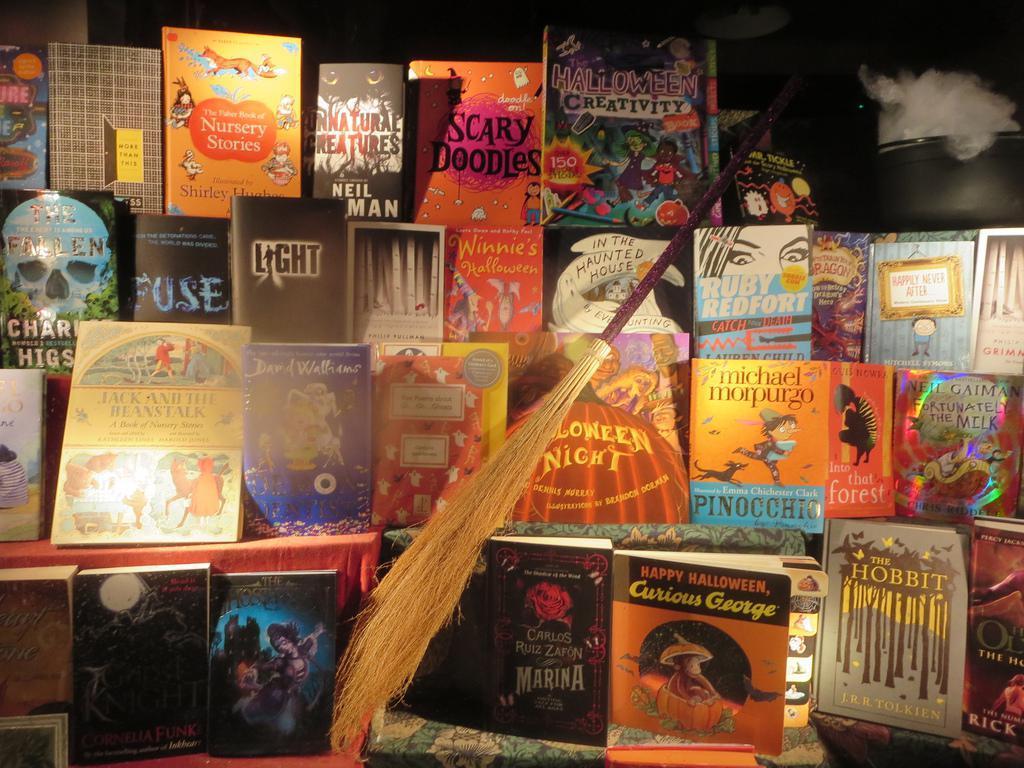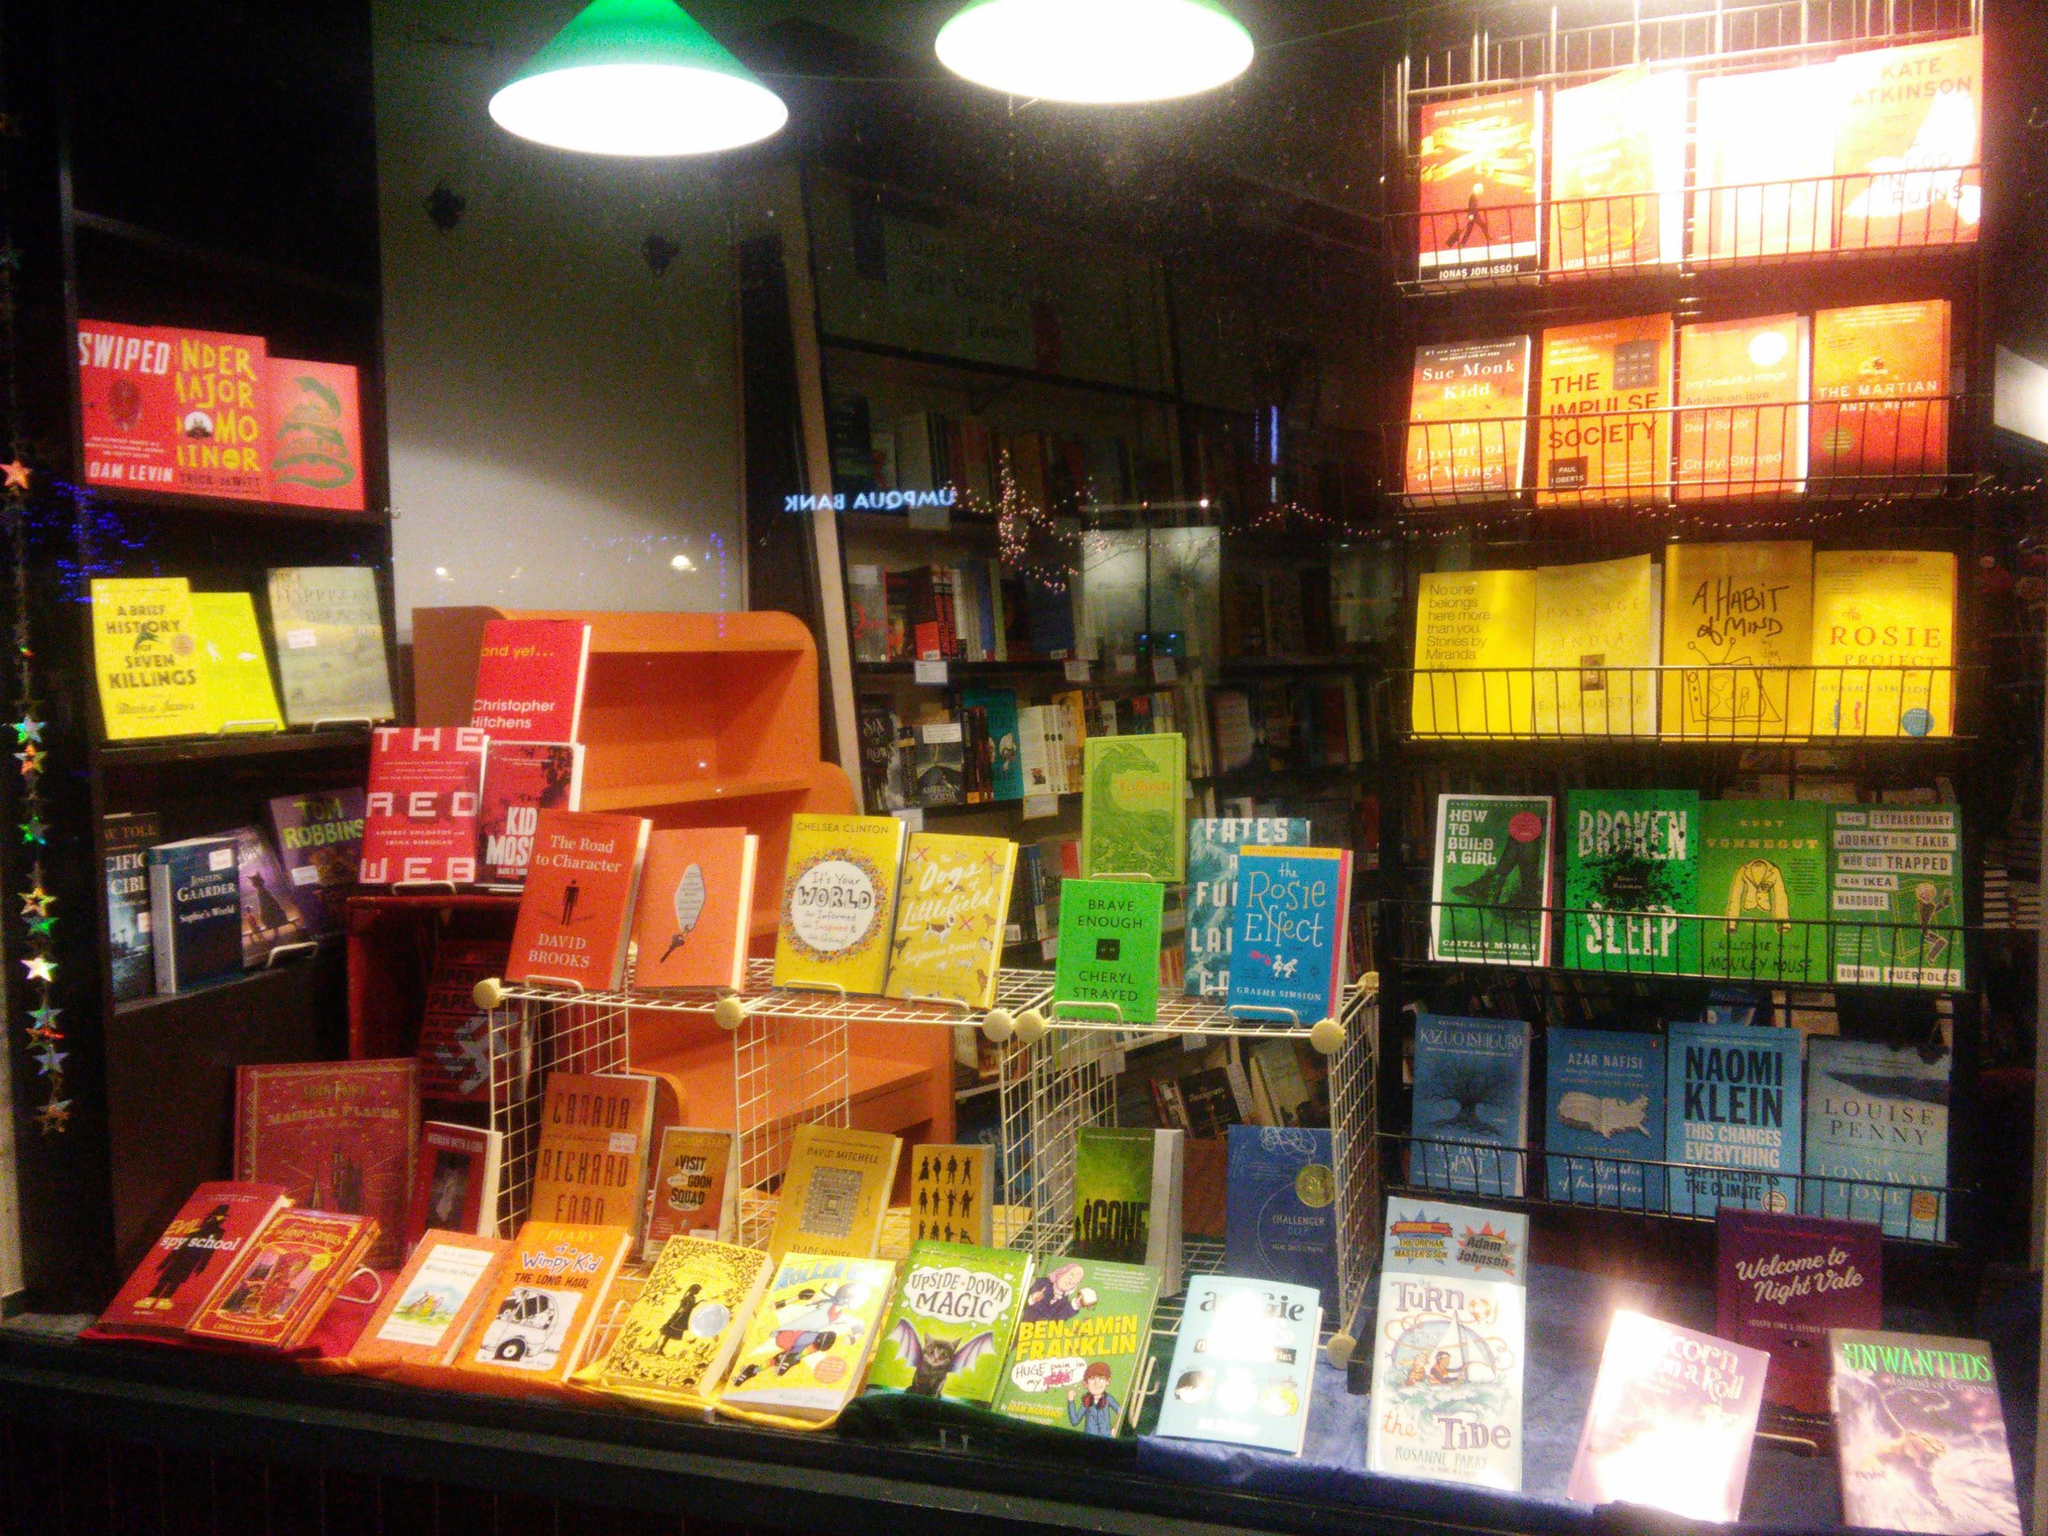The first image is the image on the left, the second image is the image on the right. For the images shown, is this caption "One image features a bookstore exterior showing a lighted interior, and something upright is outside in front of the store window." true? Answer yes or no. No. The first image is the image on the left, the second image is the image on the right. Considering the images on both sides, is "one of the two images contains books in chromatic order; there appears to be a rainbow effect created with books." valid? Answer yes or no. Yes. 